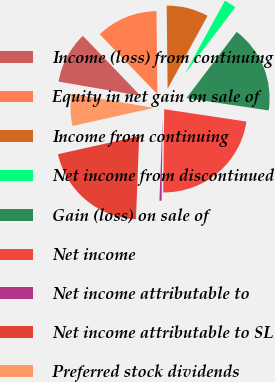<chart> <loc_0><loc_0><loc_500><loc_500><pie_chart><fcel>Income (loss) from continuing<fcel>Equity in net gain on sale of<fcel>Income from continuing<fcel>Net income from discontinued<fcel>Gain (loss) on sale of<fcel>Net income<fcel>Net income attributable to<fcel>Net income attributable to SL<fcel>Preferred stock dividends<nl><fcel>10.08%<fcel>12.01%<fcel>8.15%<fcel>2.36%<fcel>17.03%<fcel>22.83%<fcel>0.42%<fcel>20.89%<fcel>6.22%<nl></chart> 